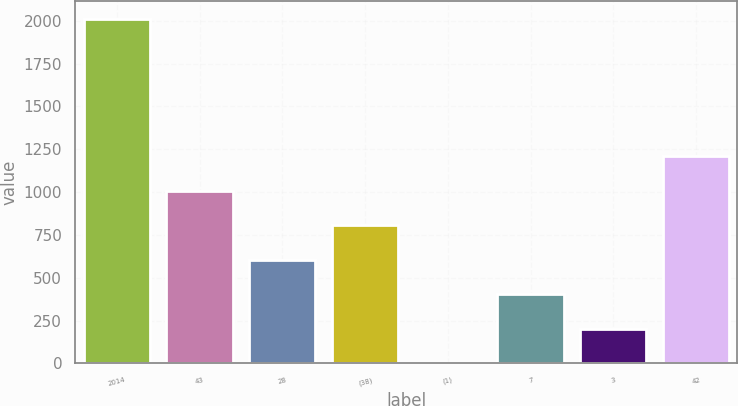Convert chart to OTSL. <chart><loc_0><loc_0><loc_500><loc_500><bar_chart><fcel>2014<fcel>43<fcel>28<fcel>(38)<fcel>(1)<fcel>7<fcel>3<fcel>42<nl><fcel>2013<fcel>1007<fcel>604.6<fcel>805.8<fcel>1<fcel>403.4<fcel>202.2<fcel>1208.2<nl></chart> 